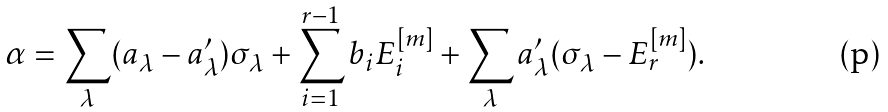<formula> <loc_0><loc_0><loc_500><loc_500>\alpha = \sum _ { \lambda } ( a _ { \lambda } - a ^ { \prime } _ { \lambda } ) \sigma _ { \lambda } + \sum _ { i = 1 } ^ { r - 1 } b _ { i } E _ { i } ^ { [ m ] } + \sum _ { \lambda } a ^ { \prime } _ { \lambda } ( \sigma _ { \lambda } - E _ { r } ^ { [ m ] } ) .</formula> 